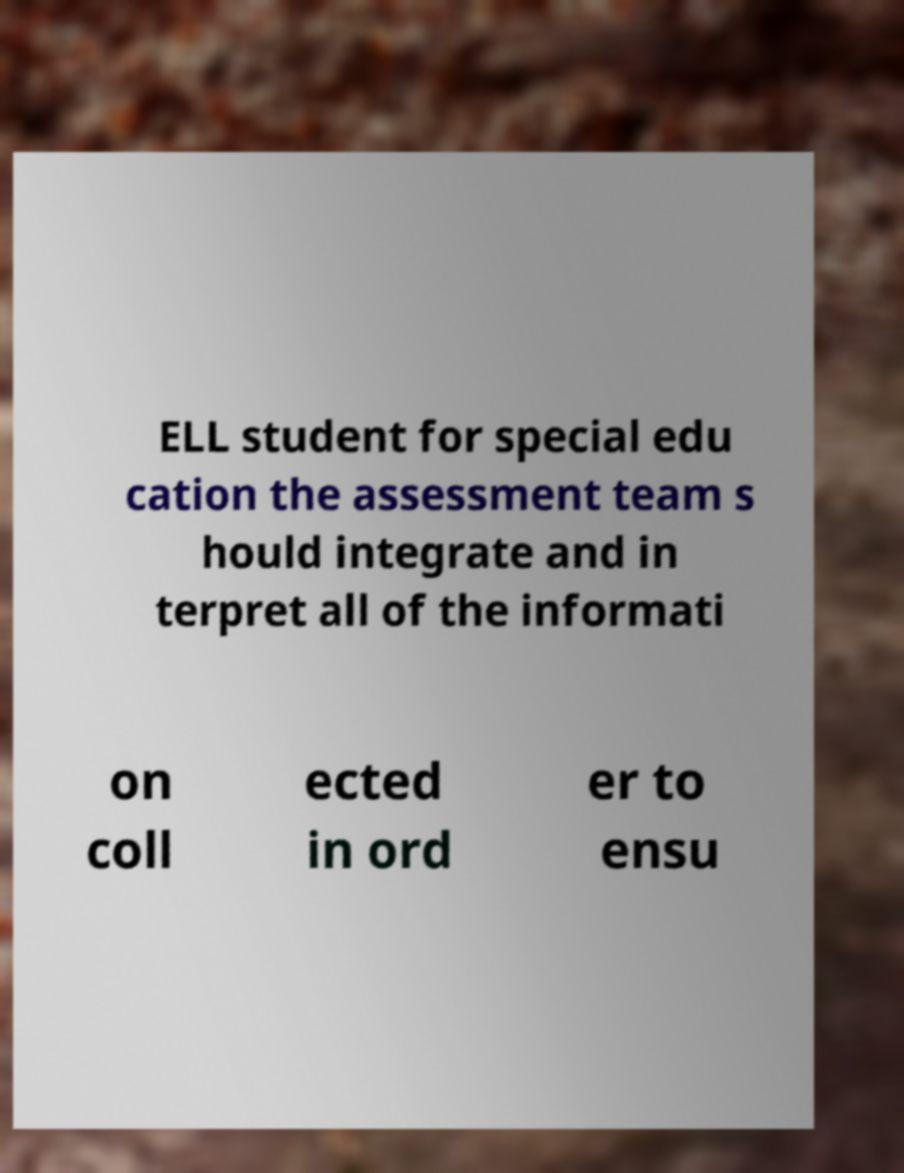Please identify and transcribe the text found in this image. ELL student for special edu cation the assessment team s hould integrate and in terpret all of the informati on coll ected in ord er to ensu 